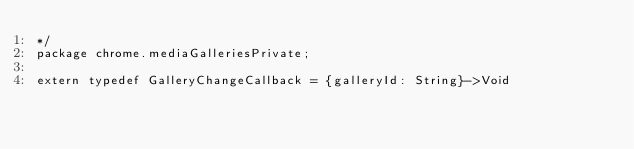<code> <loc_0><loc_0><loc_500><loc_500><_Haxe_>*/
package chrome.mediaGalleriesPrivate;

extern typedef GalleryChangeCallback = {galleryId: String}->Void

</code> 